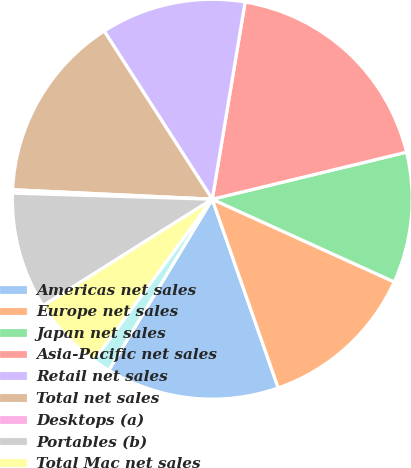Convert chart. <chart><loc_0><loc_0><loc_500><loc_500><pie_chart><fcel>Americas net sales<fcel>Europe net sales<fcel>Japan net sales<fcel>Asia-Pacific net sales<fcel>Retail net sales<fcel>Total net sales<fcel>Desktops (a)<fcel>Portables (b)<fcel>Total Mac net sales<fcel>iPod<nl><fcel>14.01%<fcel>12.86%<fcel>10.57%<fcel>18.59%<fcel>11.72%<fcel>15.15%<fcel>0.27%<fcel>9.43%<fcel>5.99%<fcel>1.41%<nl></chart> 